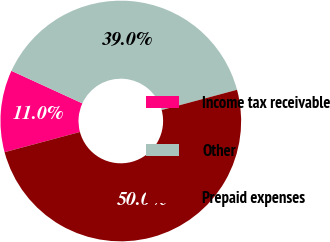Convert chart. <chart><loc_0><loc_0><loc_500><loc_500><pie_chart><fcel>Income tax receivable<fcel>Other<fcel>Prepaid expenses<nl><fcel>11.02%<fcel>38.98%<fcel>50.0%<nl></chart> 